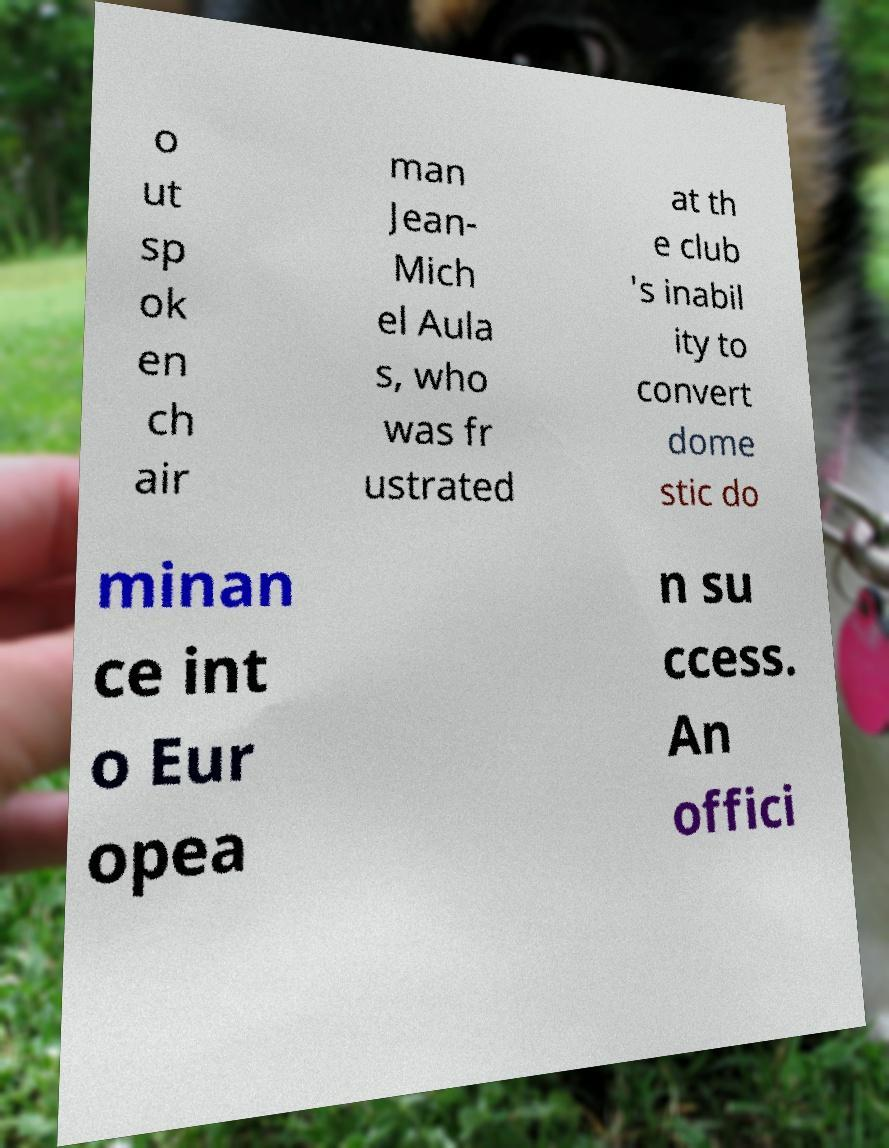What messages or text are displayed in this image? I need them in a readable, typed format. o ut sp ok en ch air man Jean- Mich el Aula s, who was fr ustrated at th e club 's inabil ity to convert dome stic do minan ce int o Eur opea n su ccess. An offici 